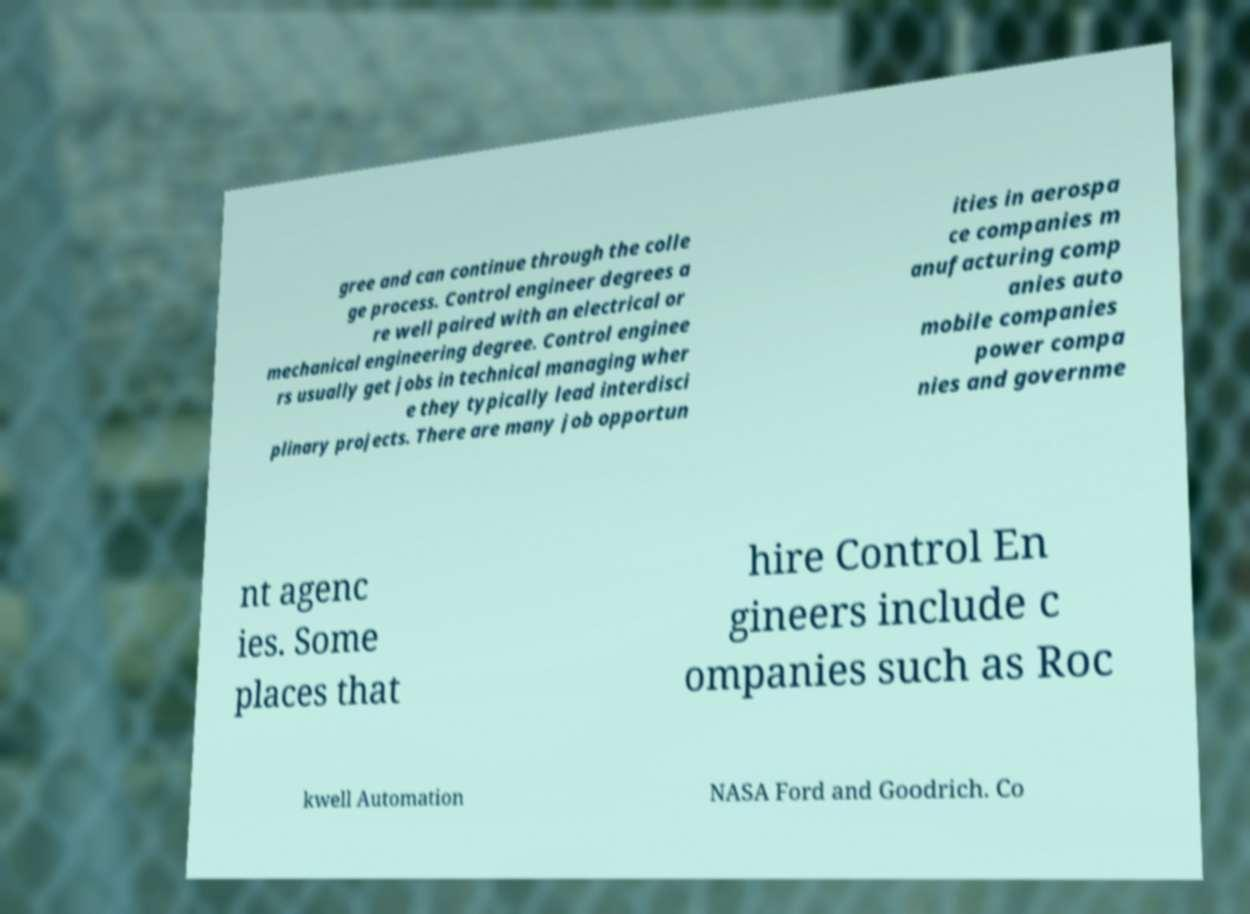Could you assist in decoding the text presented in this image and type it out clearly? gree and can continue through the colle ge process. Control engineer degrees a re well paired with an electrical or mechanical engineering degree. Control enginee rs usually get jobs in technical managing wher e they typically lead interdisci plinary projects. There are many job opportun ities in aerospa ce companies m anufacturing comp anies auto mobile companies power compa nies and governme nt agenc ies. Some places that hire Control En gineers include c ompanies such as Roc kwell Automation NASA Ford and Goodrich. Co 